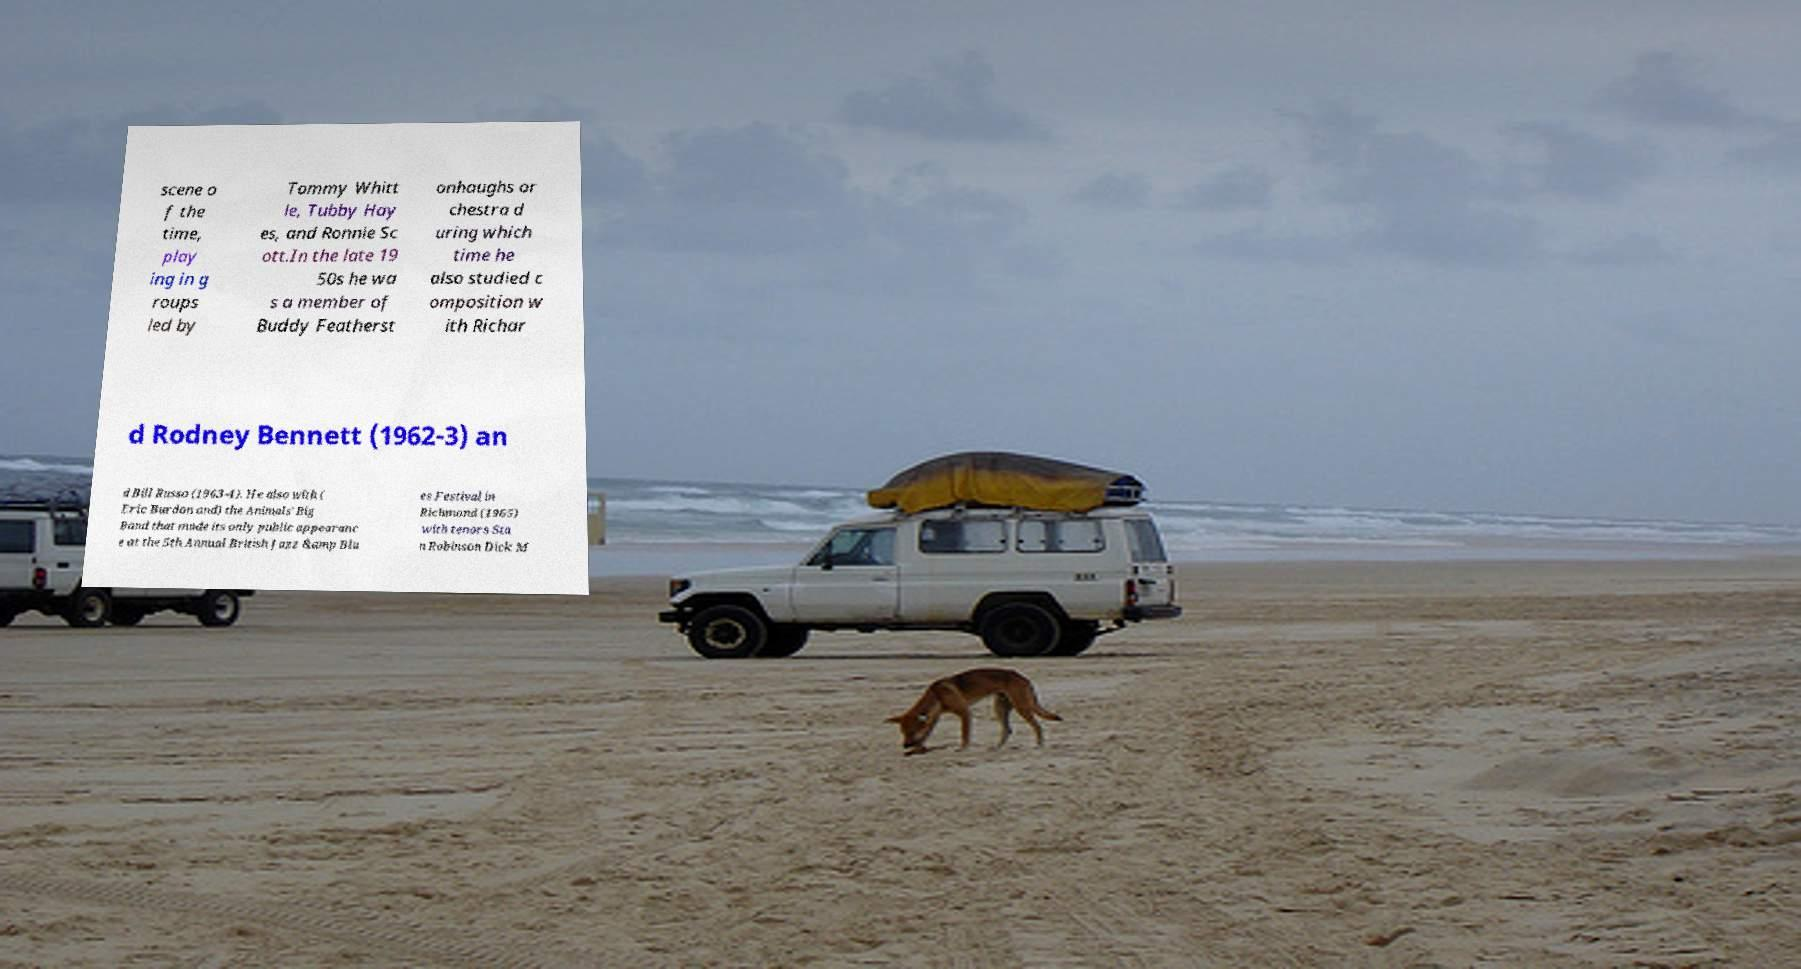Could you assist in decoding the text presented in this image and type it out clearly? scene o f the time, play ing in g roups led by Tommy Whitt le, Tubby Hay es, and Ronnie Sc ott.In the late 19 50s he wa s a member of Buddy Featherst onhaughs or chestra d uring which time he also studied c omposition w ith Richar d Rodney Bennett (1962-3) an d Bill Russo (1963-4). He also with ( Eric Burdon and) the Animals' Big Band that made its only public appearanc e at the 5th Annual British Jazz &amp Blu es Festival in Richmond (1965) with tenors Sta n Robinson Dick M 